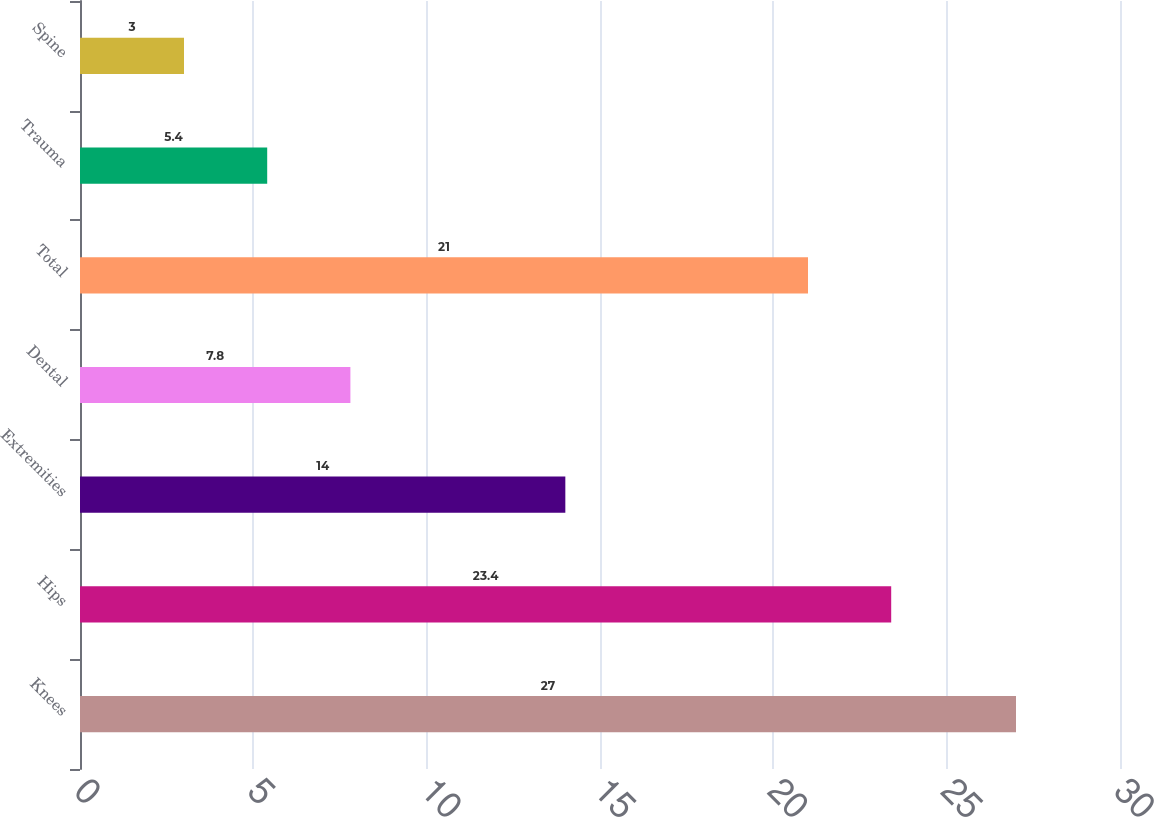Convert chart. <chart><loc_0><loc_0><loc_500><loc_500><bar_chart><fcel>Knees<fcel>Hips<fcel>Extremities<fcel>Dental<fcel>Total<fcel>Trauma<fcel>Spine<nl><fcel>27<fcel>23.4<fcel>14<fcel>7.8<fcel>21<fcel>5.4<fcel>3<nl></chart> 